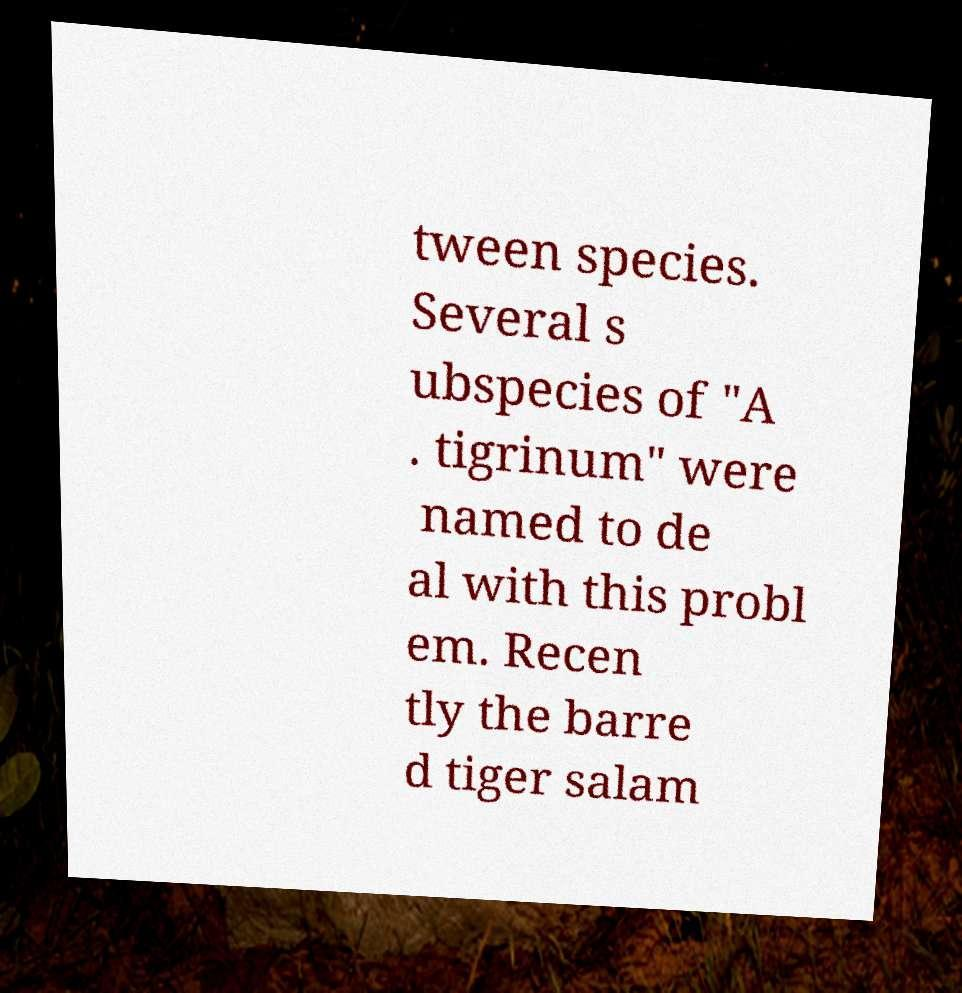Can you accurately transcribe the text from the provided image for me? tween species. Several s ubspecies of "A . tigrinum" were named to de al with this probl em. Recen tly the barre d tiger salam 